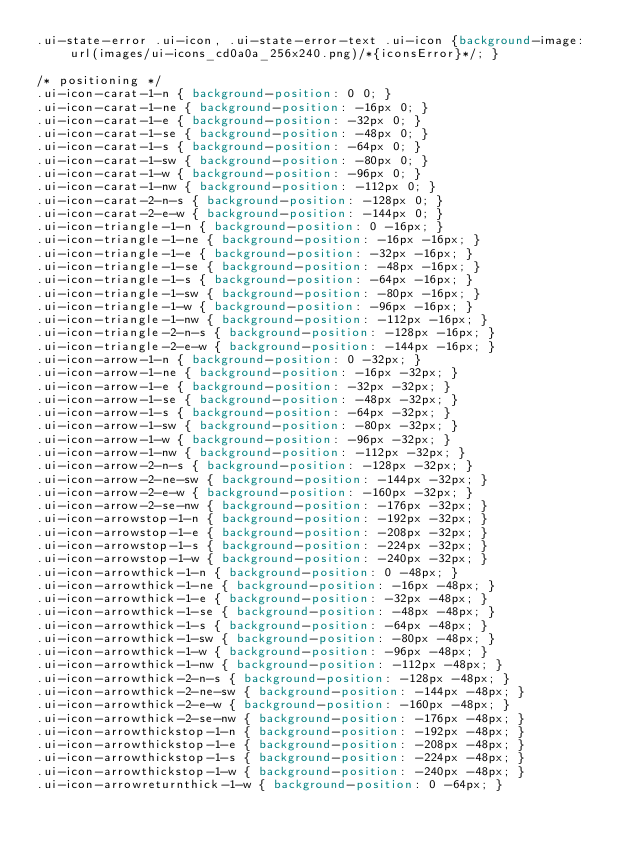Convert code to text. <code><loc_0><loc_0><loc_500><loc_500><_CSS_>.ui-state-error .ui-icon, .ui-state-error-text .ui-icon {background-image: url(images/ui-icons_cd0a0a_256x240.png)/*{iconsError}*/; }

/* positioning */
.ui-icon-carat-1-n { background-position: 0 0; }
.ui-icon-carat-1-ne { background-position: -16px 0; }
.ui-icon-carat-1-e { background-position: -32px 0; }
.ui-icon-carat-1-se { background-position: -48px 0; }
.ui-icon-carat-1-s { background-position: -64px 0; }
.ui-icon-carat-1-sw { background-position: -80px 0; }
.ui-icon-carat-1-w { background-position: -96px 0; }
.ui-icon-carat-1-nw { background-position: -112px 0; }
.ui-icon-carat-2-n-s { background-position: -128px 0; }
.ui-icon-carat-2-e-w { background-position: -144px 0; }
.ui-icon-triangle-1-n { background-position: 0 -16px; }
.ui-icon-triangle-1-ne { background-position: -16px -16px; }
.ui-icon-triangle-1-e { background-position: -32px -16px; }
.ui-icon-triangle-1-se { background-position: -48px -16px; }
.ui-icon-triangle-1-s { background-position: -64px -16px; }
.ui-icon-triangle-1-sw { background-position: -80px -16px; }
.ui-icon-triangle-1-w { background-position: -96px -16px; }
.ui-icon-triangle-1-nw { background-position: -112px -16px; }
.ui-icon-triangle-2-n-s { background-position: -128px -16px; }
.ui-icon-triangle-2-e-w { background-position: -144px -16px; }
.ui-icon-arrow-1-n { background-position: 0 -32px; }
.ui-icon-arrow-1-ne { background-position: -16px -32px; }
.ui-icon-arrow-1-e { background-position: -32px -32px; }
.ui-icon-arrow-1-se { background-position: -48px -32px; }
.ui-icon-arrow-1-s { background-position: -64px -32px; }
.ui-icon-arrow-1-sw { background-position: -80px -32px; }
.ui-icon-arrow-1-w { background-position: -96px -32px; }
.ui-icon-arrow-1-nw { background-position: -112px -32px; }
.ui-icon-arrow-2-n-s { background-position: -128px -32px; }
.ui-icon-arrow-2-ne-sw { background-position: -144px -32px; }
.ui-icon-arrow-2-e-w { background-position: -160px -32px; }
.ui-icon-arrow-2-se-nw { background-position: -176px -32px; }
.ui-icon-arrowstop-1-n { background-position: -192px -32px; }
.ui-icon-arrowstop-1-e { background-position: -208px -32px; }
.ui-icon-arrowstop-1-s { background-position: -224px -32px; }
.ui-icon-arrowstop-1-w { background-position: -240px -32px; }
.ui-icon-arrowthick-1-n { background-position: 0 -48px; }
.ui-icon-arrowthick-1-ne { background-position: -16px -48px; }
.ui-icon-arrowthick-1-e { background-position: -32px -48px; }
.ui-icon-arrowthick-1-se { background-position: -48px -48px; }
.ui-icon-arrowthick-1-s { background-position: -64px -48px; }
.ui-icon-arrowthick-1-sw { background-position: -80px -48px; }
.ui-icon-arrowthick-1-w { background-position: -96px -48px; }
.ui-icon-arrowthick-1-nw { background-position: -112px -48px; }
.ui-icon-arrowthick-2-n-s { background-position: -128px -48px; }
.ui-icon-arrowthick-2-ne-sw { background-position: -144px -48px; }
.ui-icon-arrowthick-2-e-w { background-position: -160px -48px; }
.ui-icon-arrowthick-2-se-nw { background-position: -176px -48px; }
.ui-icon-arrowthickstop-1-n { background-position: -192px -48px; }
.ui-icon-arrowthickstop-1-e { background-position: -208px -48px; }
.ui-icon-arrowthickstop-1-s { background-position: -224px -48px; }
.ui-icon-arrowthickstop-1-w { background-position: -240px -48px; }
.ui-icon-arrowreturnthick-1-w { background-position: 0 -64px; }</code> 